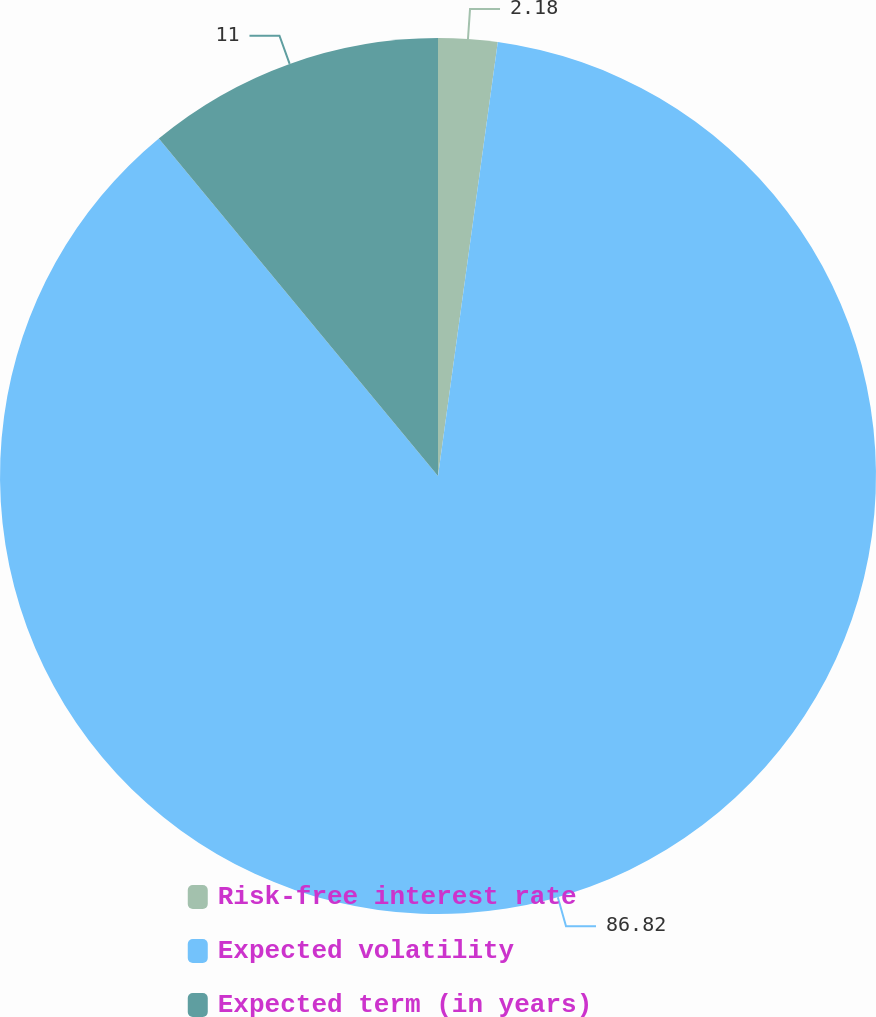Convert chart. <chart><loc_0><loc_0><loc_500><loc_500><pie_chart><fcel>Risk-free interest rate<fcel>Expected volatility<fcel>Expected term (in years)<nl><fcel>2.18%<fcel>86.82%<fcel>11.0%<nl></chart> 